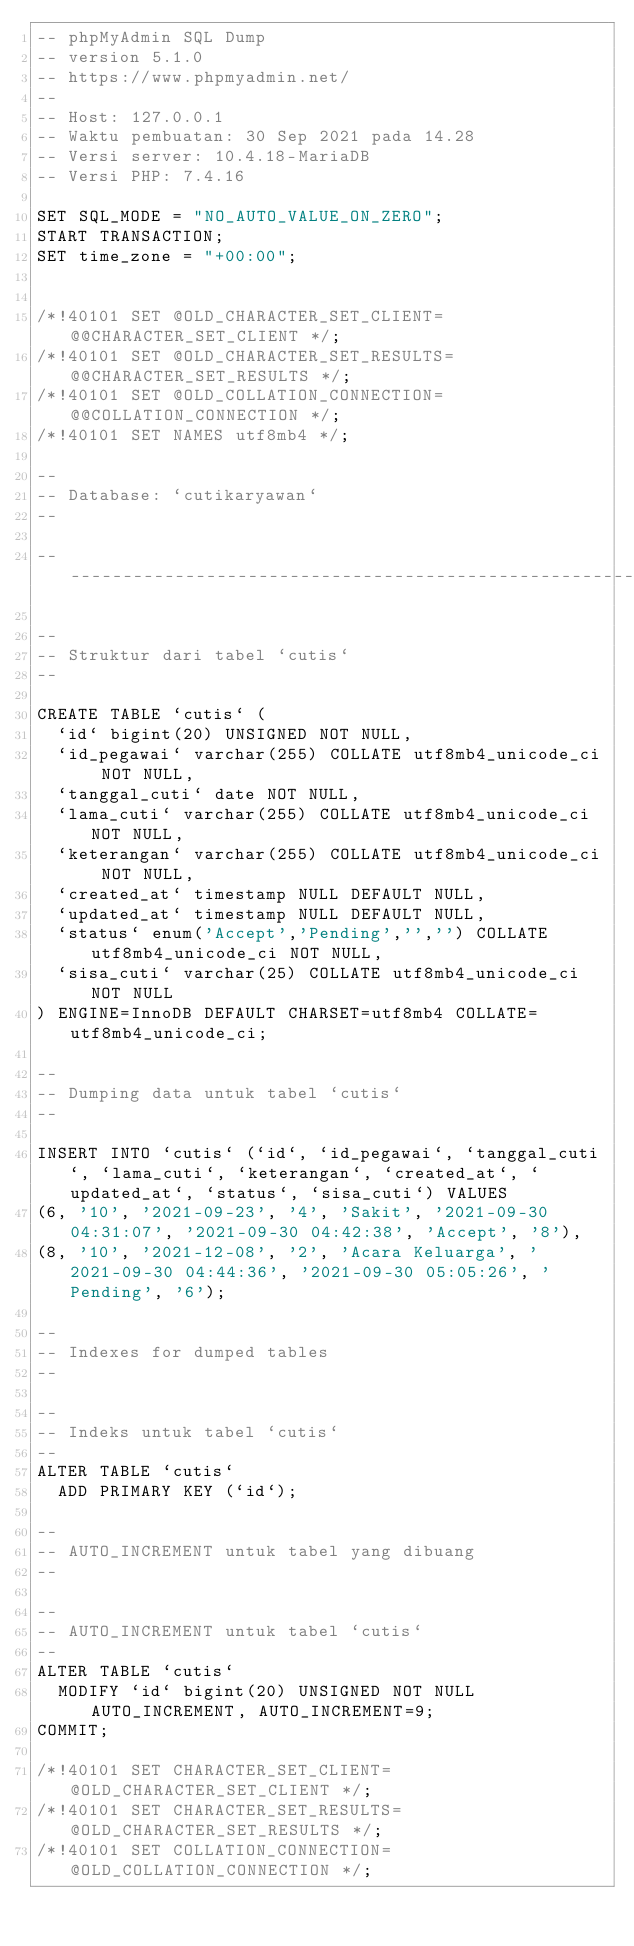Convert code to text. <code><loc_0><loc_0><loc_500><loc_500><_SQL_>-- phpMyAdmin SQL Dump
-- version 5.1.0
-- https://www.phpmyadmin.net/
--
-- Host: 127.0.0.1
-- Waktu pembuatan: 30 Sep 2021 pada 14.28
-- Versi server: 10.4.18-MariaDB
-- Versi PHP: 7.4.16

SET SQL_MODE = "NO_AUTO_VALUE_ON_ZERO";
START TRANSACTION;
SET time_zone = "+00:00";


/*!40101 SET @OLD_CHARACTER_SET_CLIENT=@@CHARACTER_SET_CLIENT */;
/*!40101 SET @OLD_CHARACTER_SET_RESULTS=@@CHARACTER_SET_RESULTS */;
/*!40101 SET @OLD_COLLATION_CONNECTION=@@COLLATION_CONNECTION */;
/*!40101 SET NAMES utf8mb4 */;

--
-- Database: `cutikaryawan`
--

-- --------------------------------------------------------

--
-- Struktur dari tabel `cutis`
--

CREATE TABLE `cutis` (
  `id` bigint(20) UNSIGNED NOT NULL,
  `id_pegawai` varchar(255) COLLATE utf8mb4_unicode_ci NOT NULL,
  `tanggal_cuti` date NOT NULL,
  `lama_cuti` varchar(255) COLLATE utf8mb4_unicode_ci NOT NULL,
  `keterangan` varchar(255) COLLATE utf8mb4_unicode_ci NOT NULL,
  `created_at` timestamp NULL DEFAULT NULL,
  `updated_at` timestamp NULL DEFAULT NULL,
  `status` enum('Accept','Pending','','') COLLATE utf8mb4_unicode_ci NOT NULL,
  `sisa_cuti` varchar(25) COLLATE utf8mb4_unicode_ci NOT NULL
) ENGINE=InnoDB DEFAULT CHARSET=utf8mb4 COLLATE=utf8mb4_unicode_ci;

--
-- Dumping data untuk tabel `cutis`
--

INSERT INTO `cutis` (`id`, `id_pegawai`, `tanggal_cuti`, `lama_cuti`, `keterangan`, `created_at`, `updated_at`, `status`, `sisa_cuti`) VALUES
(6, '10', '2021-09-23', '4', 'Sakit', '2021-09-30 04:31:07', '2021-09-30 04:42:38', 'Accept', '8'),
(8, '10', '2021-12-08', '2', 'Acara Keluarga', '2021-09-30 04:44:36', '2021-09-30 05:05:26', 'Pending', '6');

--
-- Indexes for dumped tables
--

--
-- Indeks untuk tabel `cutis`
--
ALTER TABLE `cutis`
  ADD PRIMARY KEY (`id`);

--
-- AUTO_INCREMENT untuk tabel yang dibuang
--

--
-- AUTO_INCREMENT untuk tabel `cutis`
--
ALTER TABLE `cutis`
  MODIFY `id` bigint(20) UNSIGNED NOT NULL AUTO_INCREMENT, AUTO_INCREMENT=9;
COMMIT;

/*!40101 SET CHARACTER_SET_CLIENT=@OLD_CHARACTER_SET_CLIENT */;
/*!40101 SET CHARACTER_SET_RESULTS=@OLD_CHARACTER_SET_RESULTS */;
/*!40101 SET COLLATION_CONNECTION=@OLD_COLLATION_CONNECTION */;
</code> 